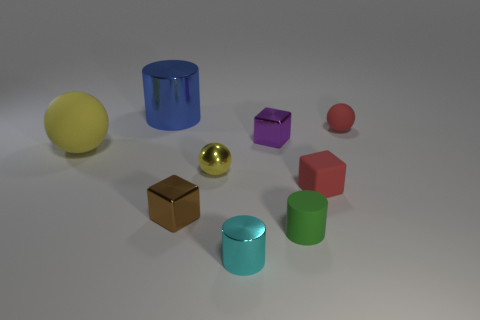What shape is the shiny thing that is in front of the tiny green matte object?
Keep it short and to the point. Cylinder. What number of objects are both in front of the big yellow rubber sphere and on the left side of the tiny cyan object?
Your answer should be very brief. 2. Are there any balls made of the same material as the blue cylinder?
Offer a very short reply. Yes. What is the size of the rubber sphere that is the same color as the matte block?
Your response must be concise. Small. How many balls are either small metal objects or large matte things?
Give a very brief answer. 2. What size is the purple metal thing?
Your answer should be compact. Small. What number of small green cylinders are behind the tiny brown object?
Your response must be concise. 0. There is a matte ball behind the matte object that is on the left side of the tiny cyan object; what size is it?
Your response must be concise. Small. There is a red object behind the yellow rubber object; is its shape the same as the rubber thing on the left side of the tiny yellow shiny sphere?
Offer a terse response. Yes. There is a yellow metallic object behind the tiny red matte object that is in front of the big matte object; what shape is it?
Ensure brevity in your answer.  Sphere. 